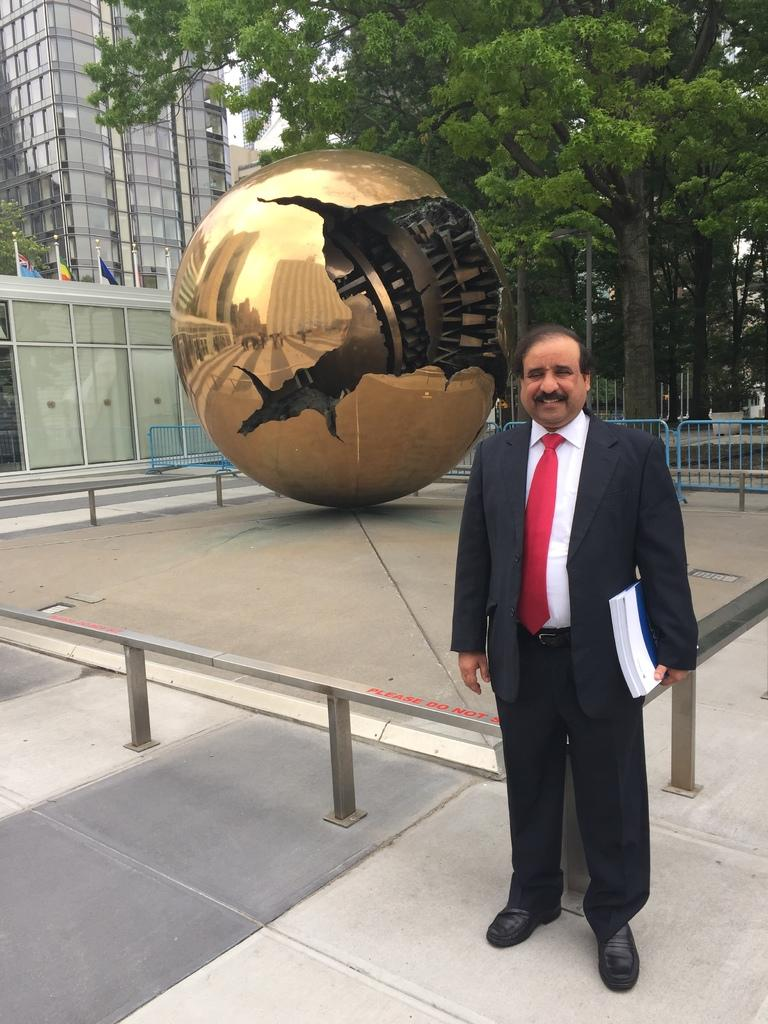Who is present in the image? There is a person in the image. What is the person's facial expression? The person is smiling. What is the person wearing? The person is wearing a coat. What is the person holding? The person is holding books. What type of fence is visible in the image? There is a metal grill fence in the image. What type of vegetation is present in the image? There are trees in the image. What type of structures are visible in the image? There are buildings in the image. How does the person stop the rainstorm in the image? There is no rainstorm present in the image, so the person cannot stop it. 